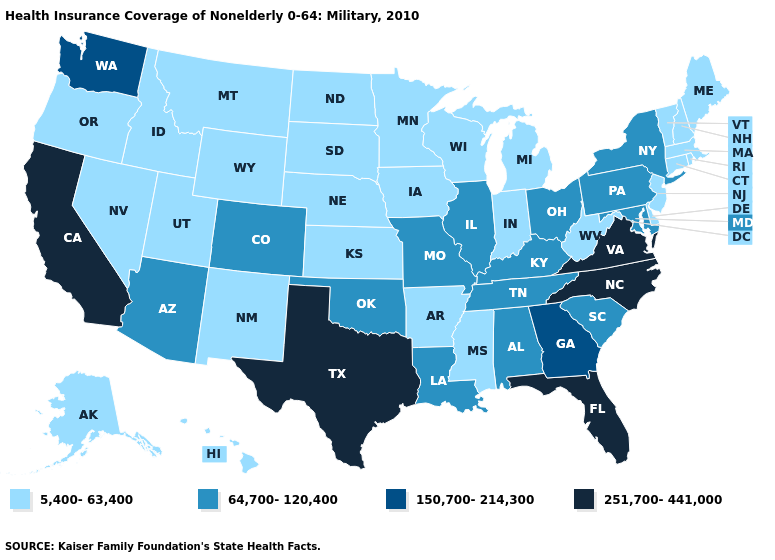What is the value of Oklahoma?
Write a very short answer. 64,700-120,400. Name the states that have a value in the range 251,700-441,000?
Answer briefly. California, Florida, North Carolina, Texas, Virginia. What is the value of New Jersey?
Write a very short answer. 5,400-63,400. Name the states that have a value in the range 5,400-63,400?
Give a very brief answer. Alaska, Arkansas, Connecticut, Delaware, Hawaii, Idaho, Indiana, Iowa, Kansas, Maine, Massachusetts, Michigan, Minnesota, Mississippi, Montana, Nebraska, Nevada, New Hampshire, New Jersey, New Mexico, North Dakota, Oregon, Rhode Island, South Dakota, Utah, Vermont, West Virginia, Wisconsin, Wyoming. What is the value of Massachusetts?
Be succinct. 5,400-63,400. Which states have the lowest value in the West?
Give a very brief answer. Alaska, Hawaii, Idaho, Montana, Nevada, New Mexico, Oregon, Utah, Wyoming. Does Indiana have the highest value in the USA?
Write a very short answer. No. What is the value of Nebraska?
Answer briefly. 5,400-63,400. Does the first symbol in the legend represent the smallest category?
Give a very brief answer. Yes. Name the states that have a value in the range 5,400-63,400?
Short answer required. Alaska, Arkansas, Connecticut, Delaware, Hawaii, Idaho, Indiana, Iowa, Kansas, Maine, Massachusetts, Michigan, Minnesota, Mississippi, Montana, Nebraska, Nevada, New Hampshire, New Jersey, New Mexico, North Dakota, Oregon, Rhode Island, South Dakota, Utah, Vermont, West Virginia, Wisconsin, Wyoming. What is the lowest value in the South?
Keep it brief. 5,400-63,400. Which states have the highest value in the USA?
Keep it brief. California, Florida, North Carolina, Texas, Virginia. Does the map have missing data?
Answer briefly. No. What is the value of Georgia?
Quick response, please. 150,700-214,300. Among the states that border Wisconsin , which have the lowest value?
Answer briefly. Iowa, Michigan, Minnesota. 